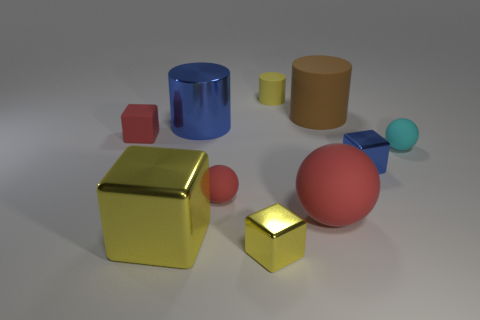Subtract all tiny balls. How many balls are left? 1 Subtract all blue spheres. How many yellow cubes are left? 2 Subtract all red blocks. How many blocks are left? 3 Subtract 1 cubes. How many cubes are left? 3 Subtract all blocks. How many objects are left? 6 Subtract all purple cylinders. Subtract all green balls. How many cylinders are left? 3 Subtract 0 green cylinders. How many objects are left? 10 Subtract all big yellow shiny things. Subtract all tiny cyan rubber objects. How many objects are left? 8 Add 3 metallic things. How many metallic things are left? 7 Add 5 small yellow objects. How many small yellow objects exist? 7 